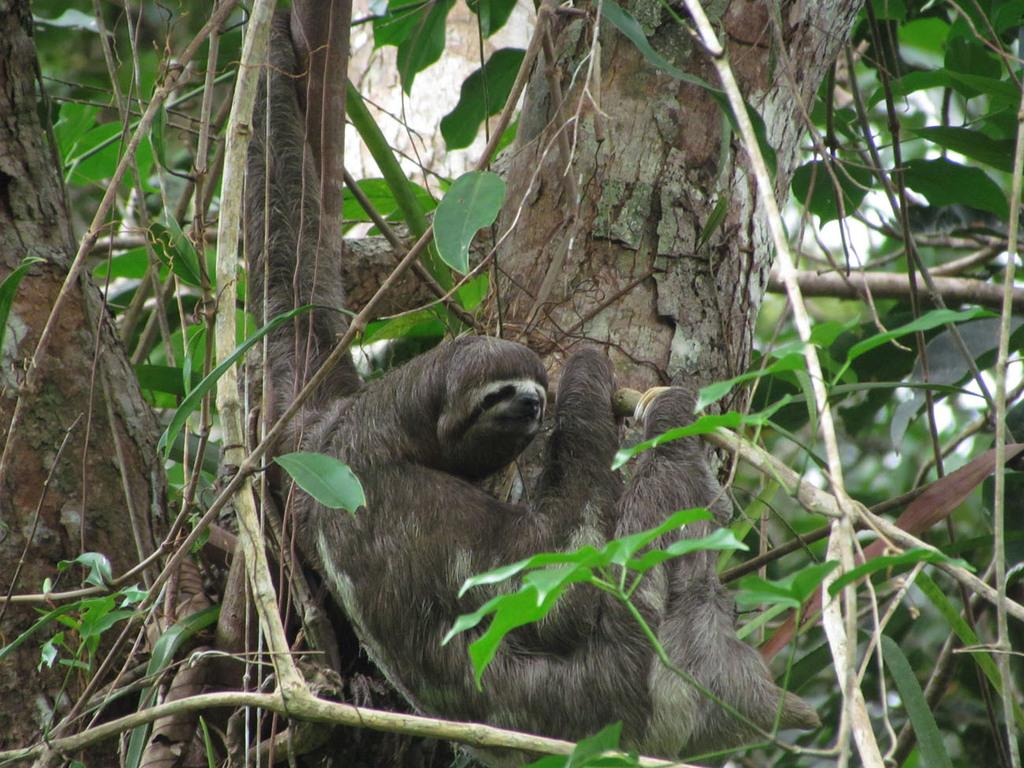What type of animal can be seen in the image? There is an animal in the image, but its specific type cannot be determined from the provided facts. Where is the animal located in the image? The animal is on a tree in the image. What is the central focus of the image? The tree is in the center of the image. What type of bread can be seen in the fog in the image? There is no bread or fog present in the image; it features an animal on a tree. What type of authority figure is depicted in the image? There is no authority figure present in the image; it features an animal on a tree. 